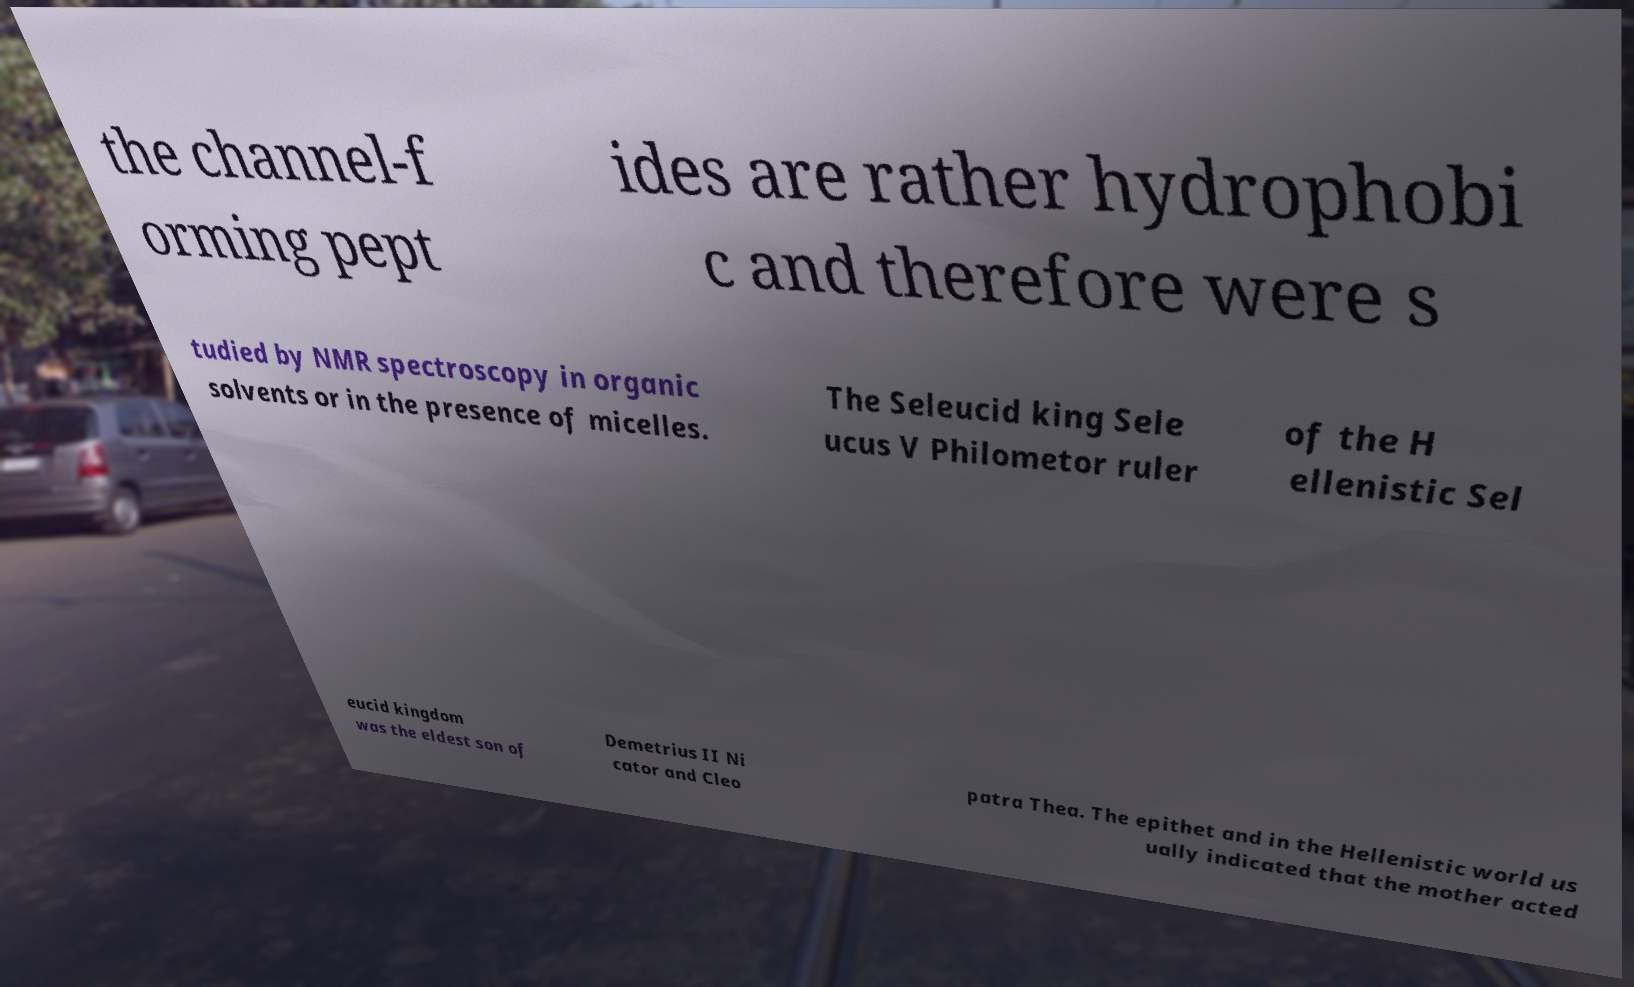Please identify and transcribe the text found in this image. the channel-f orming pept ides are rather hydrophobi c and therefore were s tudied by NMR spectroscopy in organic solvents or in the presence of micelles. The Seleucid king Sele ucus V Philometor ruler of the H ellenistic Sel eucid kingdom was the eldest son of Demetrius II Ni cator and Cleo patra Thea. The epithet and in the Hellenistic world us ually indicated that the mother acted 